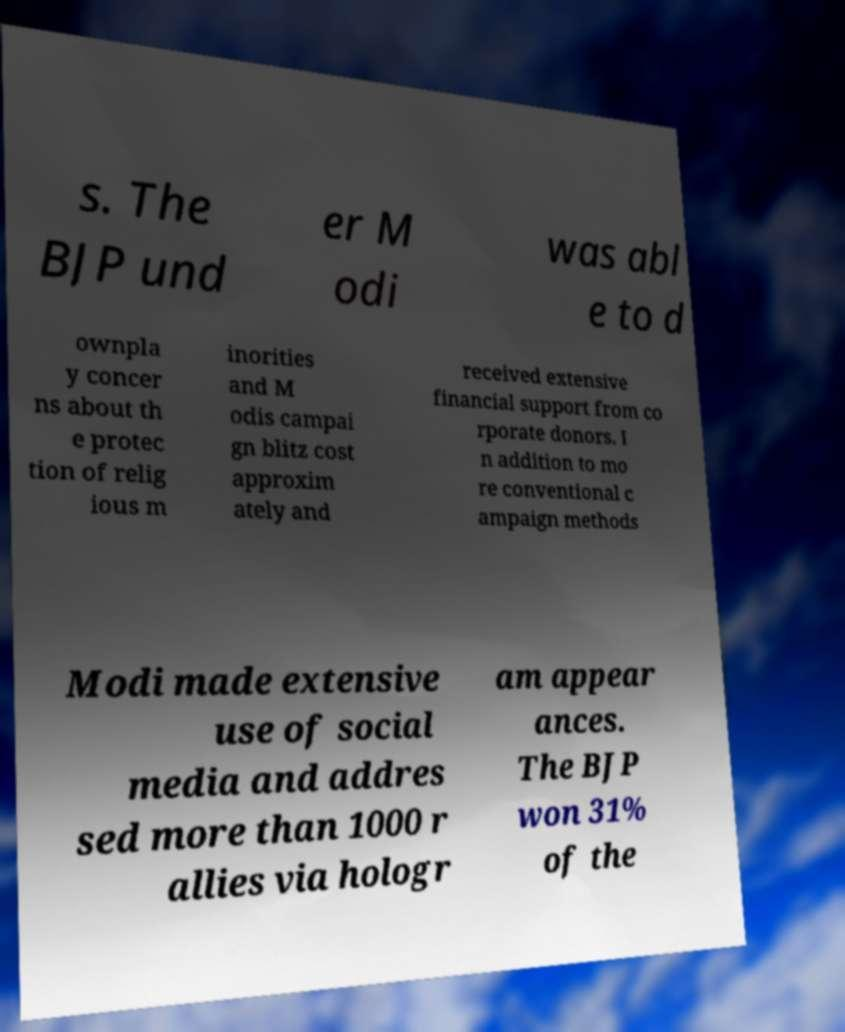Could you extract and type out the text from this image? s. The BJP und er M odi was abl e to d ownpla y concer ns about th e protec tion of relig ious m inorities and M odis campai gn blitz cost approxim ately and received extensive financial support from co rporate donors. I n addition to mo re conventional c ampaign methods Modi made extensive use of social media and addres sed more than 1000 r allies via hologr am appear ances. The BJP won 31% of the 